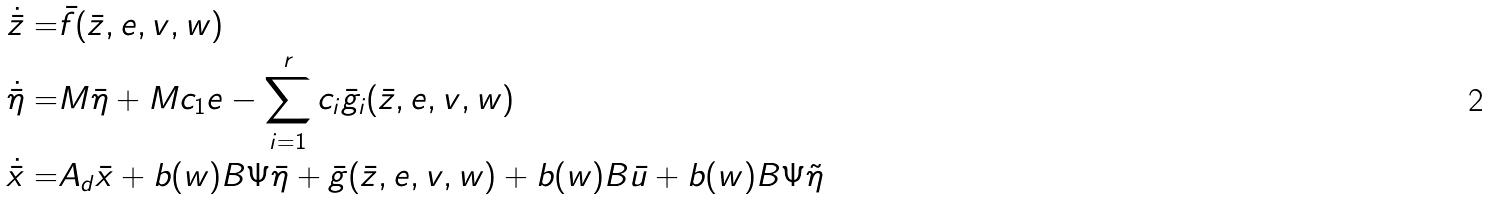<formula> <loc_0><loc_0><loc_500><loc_500>\dot { \bar { z } } = & \bar { f } ( \bar { z } , e , v , w ) \\ \dot { \bar { \eta } } = & M \bar { \eta } + M c _ { 1 } e - \sum _ { i = 1 } ^ { r } c _ { i } \bar { g } _ { i } ( \bar { z } , e , v , w ) \\ \dot { \bar { x } } = & A _ { d } \bar { x } + b ( w ) B \Psi \bar { \eta } + \bar { g } ( \bar { z } , e , v , w ) + b ( w ) B \bar { u } + b ( w ) B \Psi \tilde { \eta } \\</formula> 